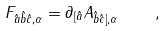Convert formula to latex. <formula><loc_0><loc_0><loc_500><loc_500>F _ { \hat { a } \hat { b } \hat { c } , \alpha } = \partial _ { [ \hat { a } } A _ { \hat { b } \hat { c } ] , \alpha } \quad ,</formula> 